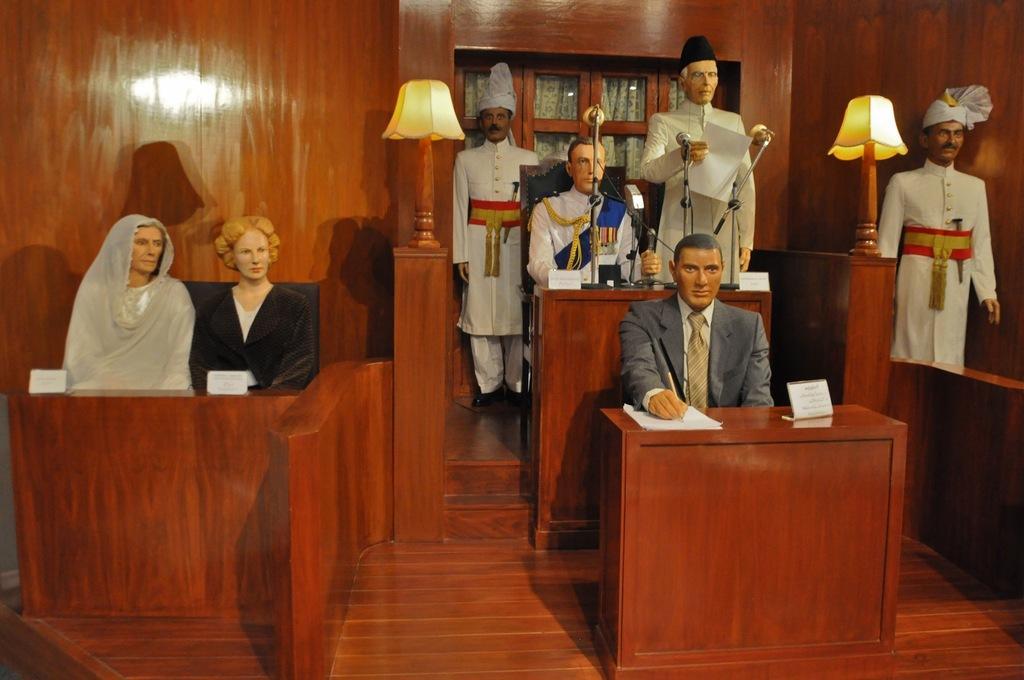Can you describe this image briefly? In this picture we can see statues and lamps. We can see boards, microphones, papers and objects on tables. In the background of the image we can see wooden wall and glass, through glass we can see curtain. 